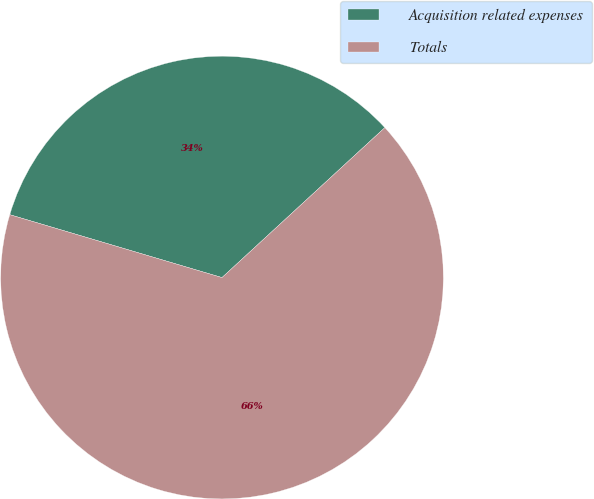Convert chart to OTSL. <chart><loc_0><loc_0><loc_500><loc_500><pie_chart><fcel>Acquisition related expenses<fcel>Totals<nl><fcel>33.57%<fcel>66.43%<nl></chart> 